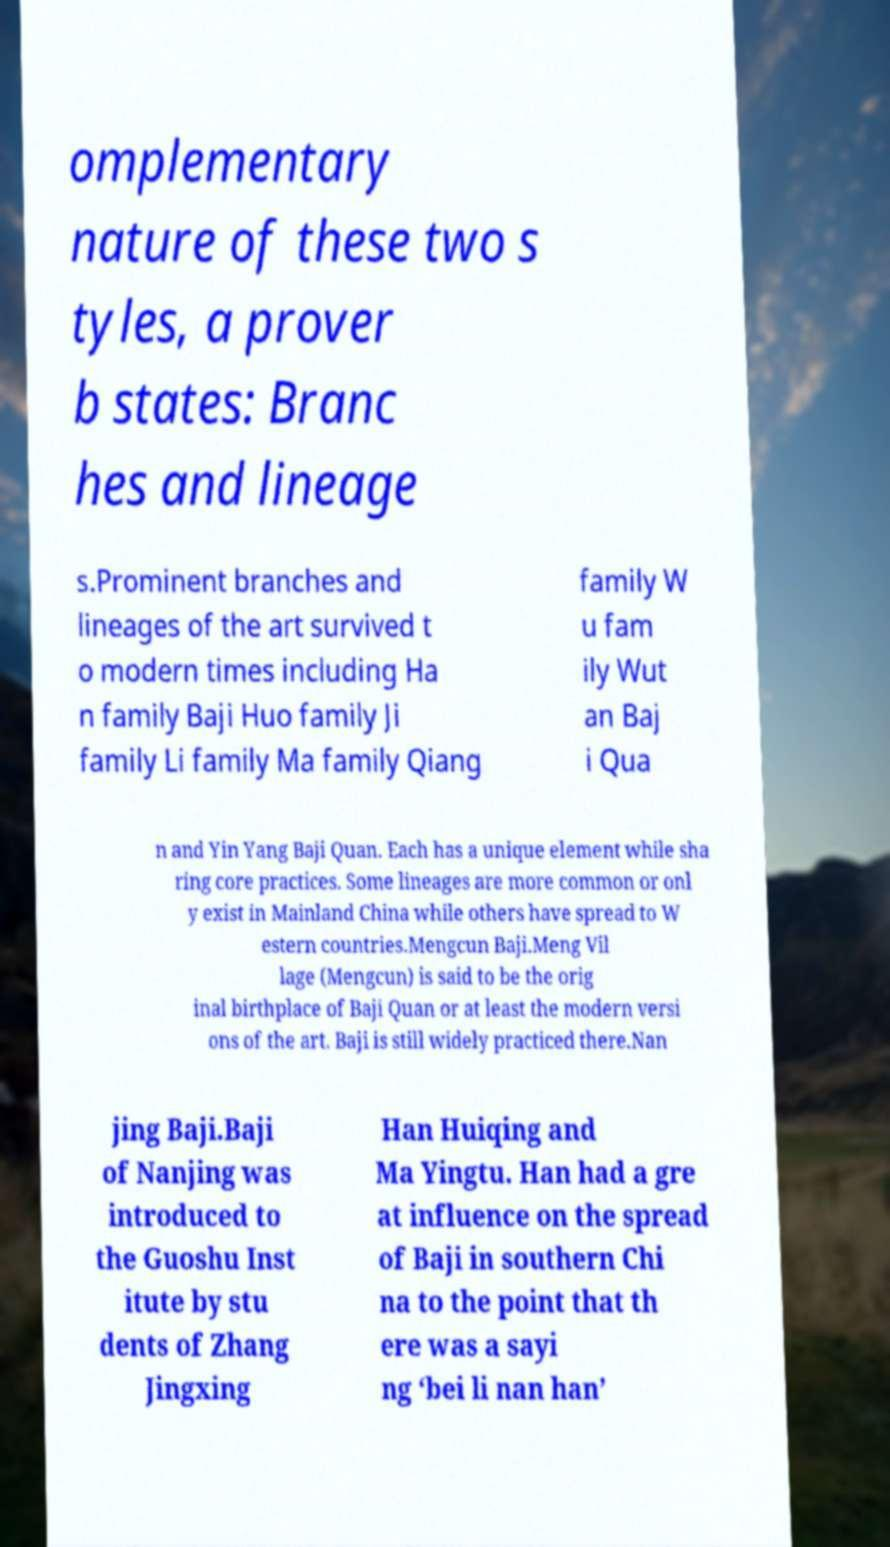For documentation purposes, I need the text within this image transcribed. Could you provide that? omplementary nature of these two s tyles, a prover b states: Branc hes and lineage s.Prominent branches and lineages of the art survived t o modern times including Ha n family Baji Huo family Ji family Li family Ma family Qiang family W u fam ily Wut an Baj i Qua n and Yin Yang Baji Quan. Each has a unique element while sha ring core practices. Some lineages are more common or onl y exist in Mainland China while others have spread to W estern countries.Mengcun Baji.Meng Vil lage (Mengcun) is said to be the orig inal birthplace of Baji Quan or at least the modern versi ons of the art. Baji is still widely practiced there.Nan jing Baji.Baji of Nanjing was introduced to the Guoshu Inst itute by stu dents of Zhang Jingxing Han Huiqing and Ma Yingtu. Han had a gre at influence on the spread of Baji in southern Chi na to the point that th ere was a sayi ng ‘bei li nan han’ 